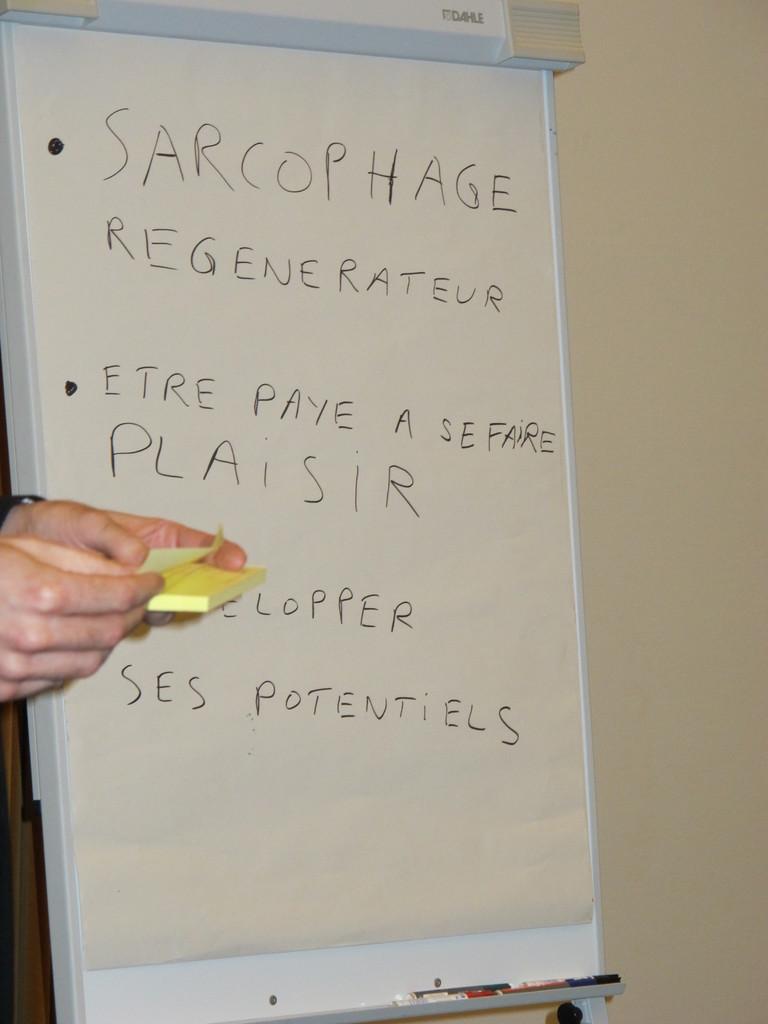What kind of regenerateur?
Ensure brevity in your answer.  Sarcophage. What is the last word on this sign?
Your answer should be very brief. Potentiels. 